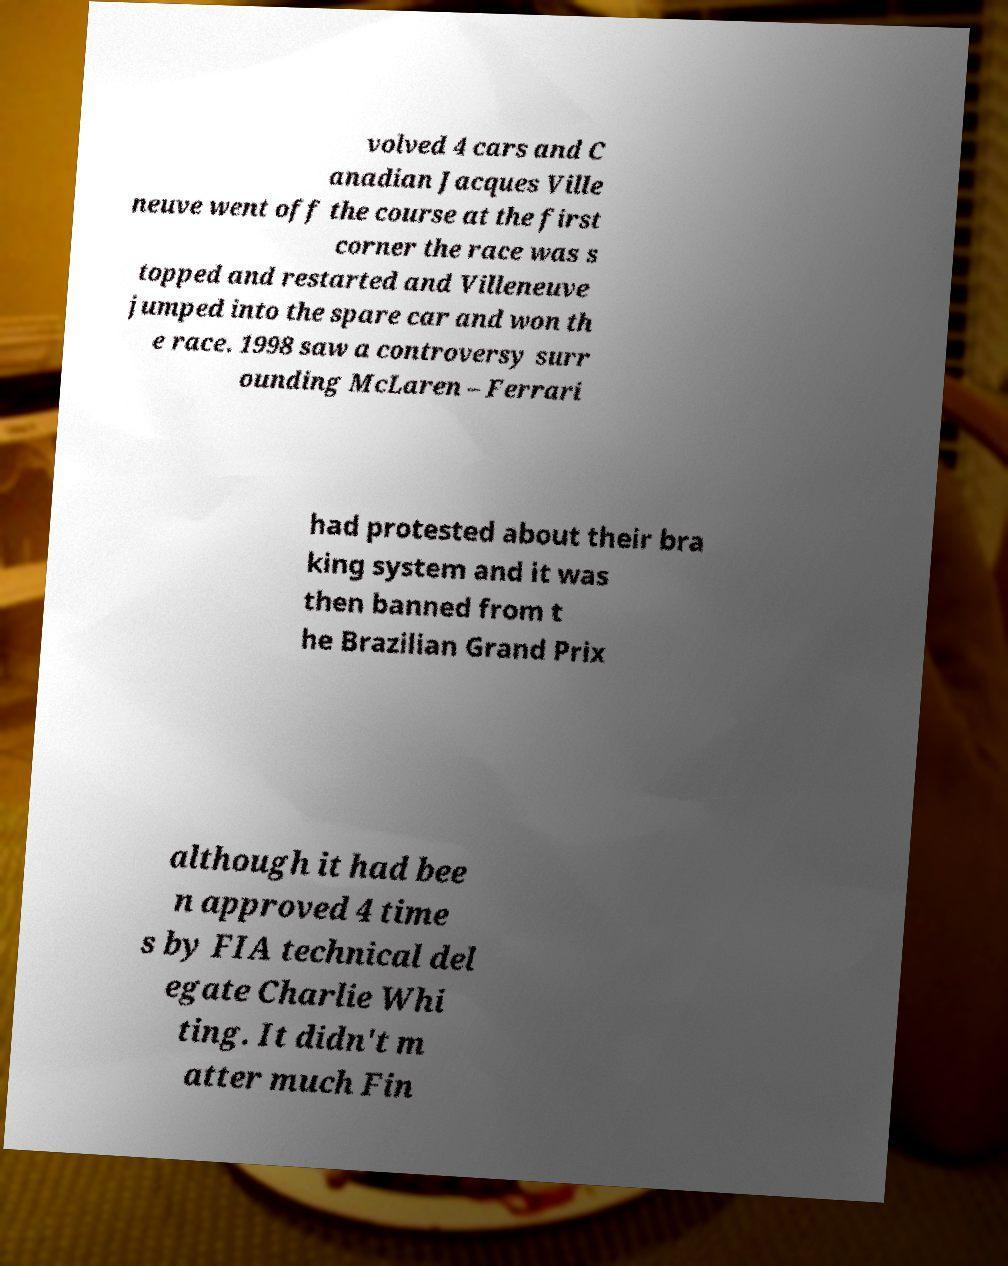There's text embedded in this image that I need extracted. Can you transcribe it verbatim? volved 4 cars and C anadian Jacques Ville neuve went off the course at the first corner the race was s topped and restarted and Villeneuve jumped into the spare car and won th e race. 1998 saw a controversy surr ounding McLaren – Ferrari had protested about their bra king system and it was then banned from t he Brazilian Grand Prix although it had bee n approved 4 time s by FIA technical del egate Charlie Whi ting. It didn't m atter much Fin 